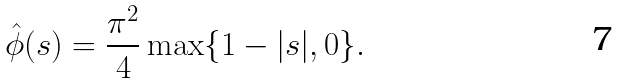<formula> <loc_0><loc_0><loc_500><loc_500>\hat { \phi } ( s ) = \frac { \pi ^ { 2 } } { 4 } \max \{ 1 - | s | , 0 \} .</formula> 